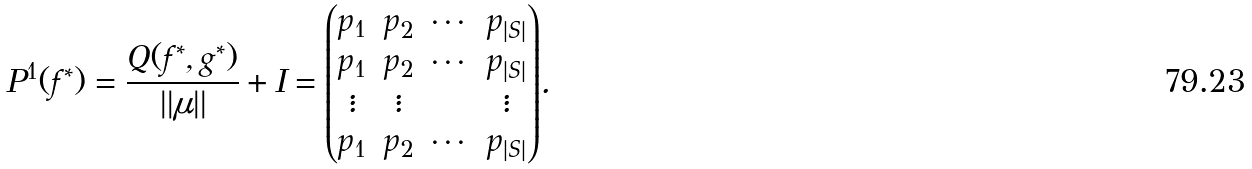Convert formula to latex. <formula><loc_0><loc_0><loc_500><loc_500>P ^ { 1 } ( f ^ { * } ) = \frac { Q ( f ^ { * } , g ^ { * } ) } { | | \mu | | } + I = \begin{matrix} \begin{pmatrix} p _ { 1 } & p _ { 2 } & \cdots & p _ { | S | } \\ p _ { 1 } & p _ { 2 } & \cdots & p _ { | S | } \\ \vdots & \vdots & & \vdots \\ p _ { 1 } & p _ { 2 } & \cdots & p _ { | S | } \end{pmatrix} \end{matrix} .</formula> 